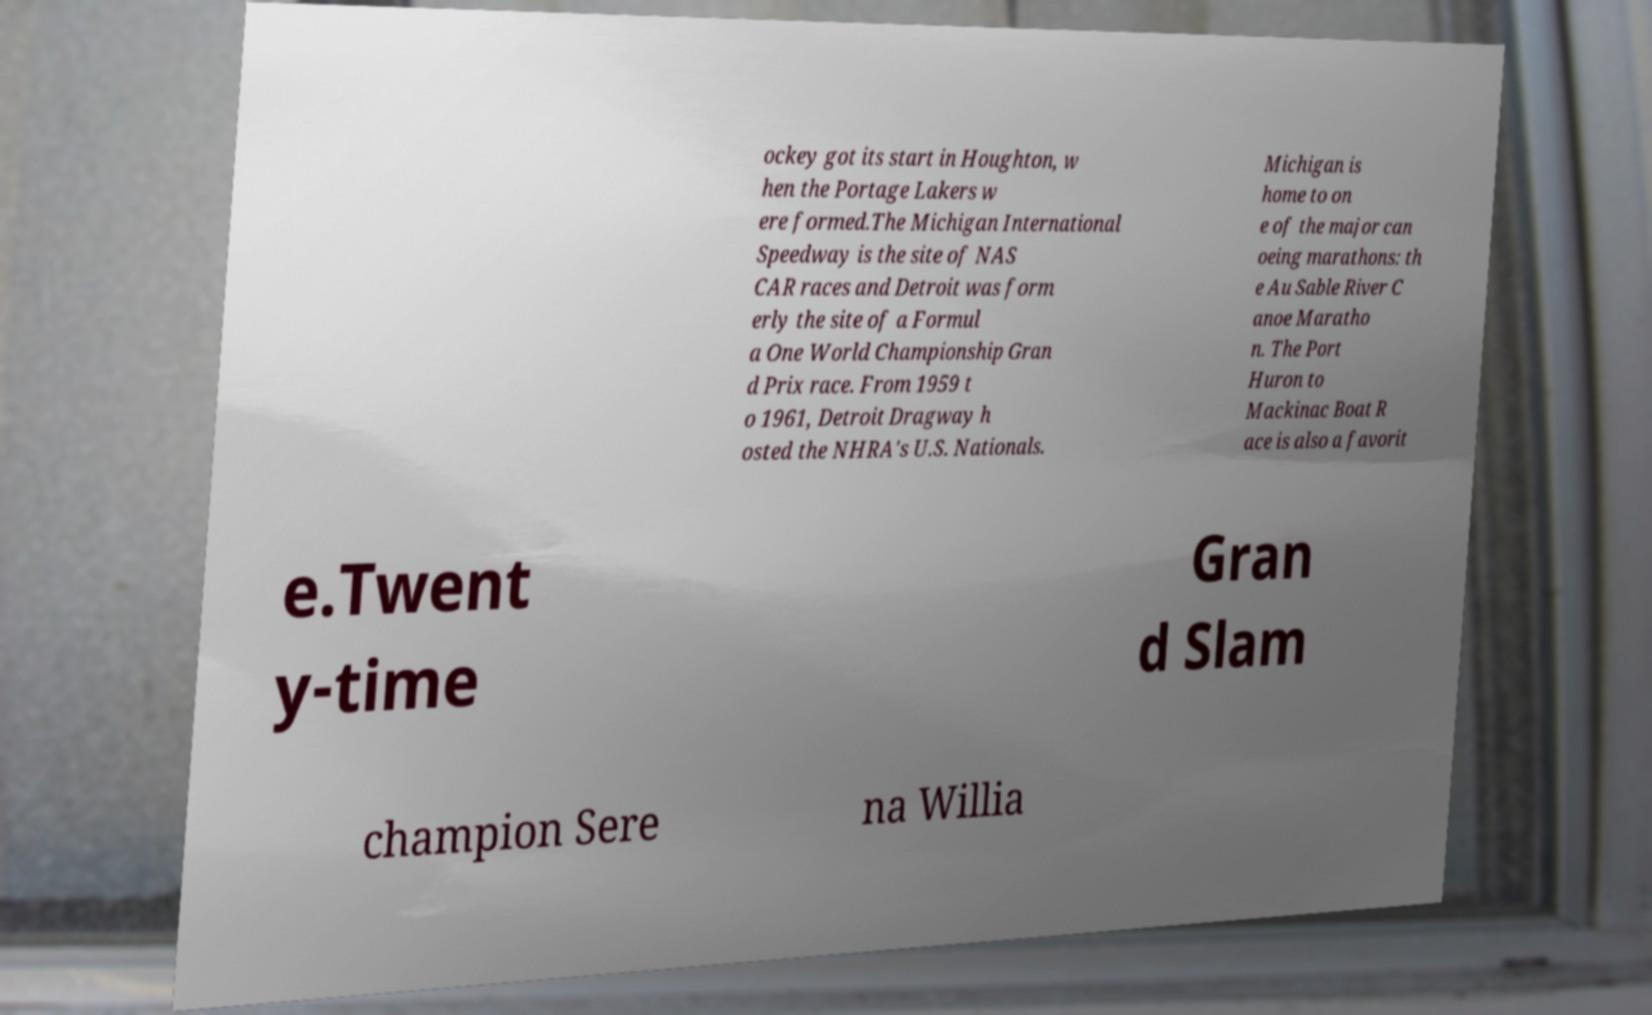Can you read and provide the text displayed in the image?This photo seems to have some interesting text. Can you extract and type it out for me? ockey got its start in Houghton, w hen the Portage Lakers w ere formed.The Michigan International Speedway is the site of NAS CAR races and Detroit was form erly the site of a Formul a One World Championship Gran d Prix race. From 1959 t o 1961, Detroit Dragway h osted the NHRA's U.S. Nationals. Michigan is home to on e of the major can oeing marathons: th e Au Sable River C anoe Maratho n. The Port Huron to Mackinac Boat R ace is also a favorit e.Twent y-time Gran d Slam champion Sere na Willia 